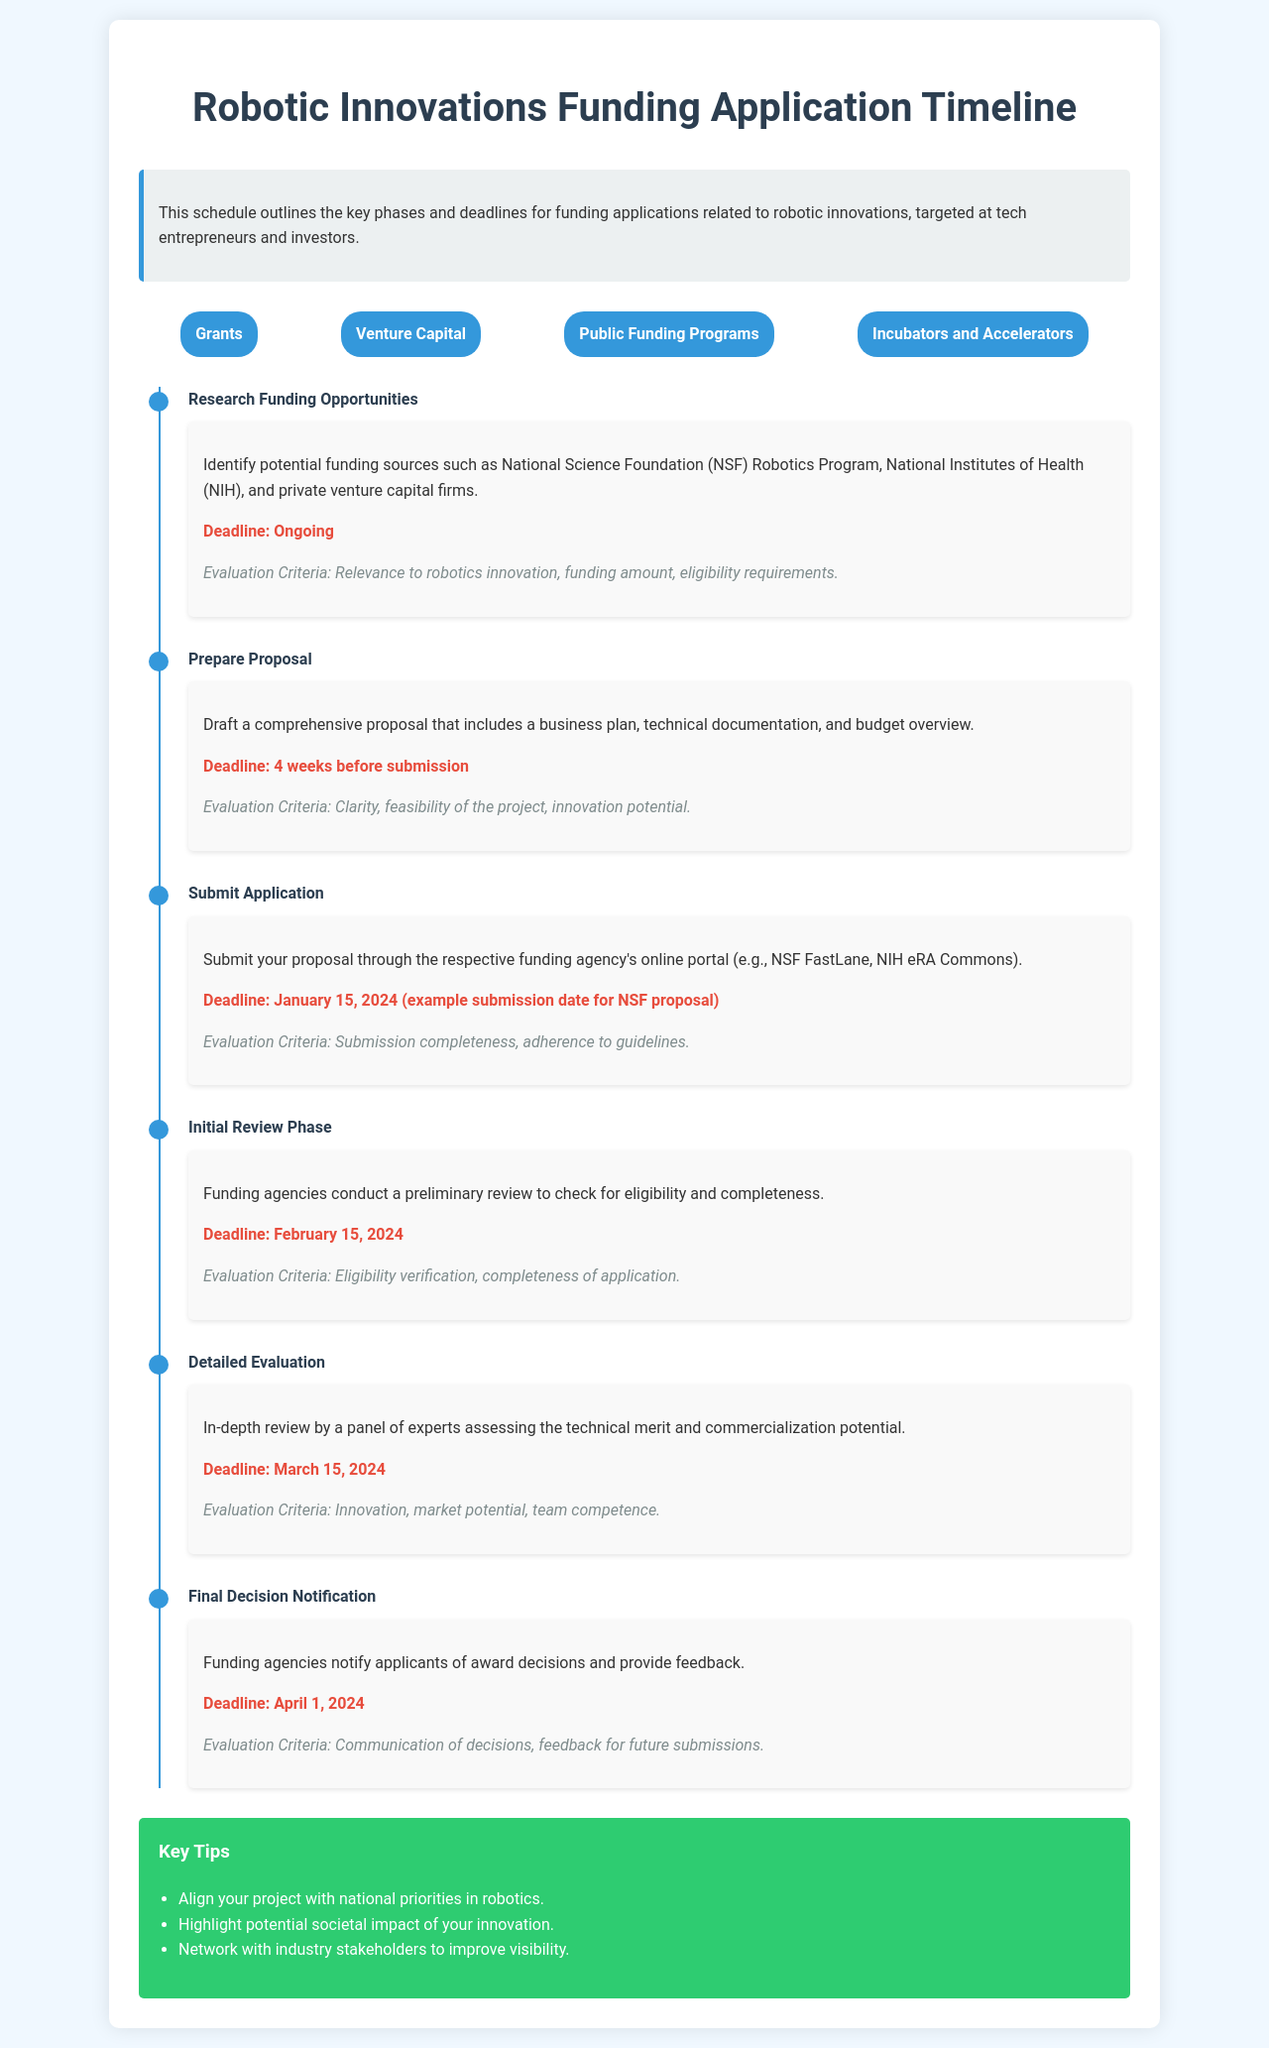what is the deadline for proposal preparation? The proposal preparation deadline is four weeks before the application submission date.
Answer: 4 weeks before submission what is the deadline for submitting the application? The application submission deadline is explicitly stated in the timeline.
Answer: January 15, 2024 what happens during the Initial Review Phase? The Initial Review Phase involves a preliminary check for eligibility and completeness by funding agencies.
Answer: Eligibility check what is the focus area related to government funding? One of the focus areas listed in the document pertains to government support initiatives.
Answer: Public Funding Programs what is evaluated during the Detailed Evaluation phase? The Detailed Evaluation phase assesses the technical merit and commercialization potential.
Answer: Technical merit and commercialization potential how long does it take until applicants are notified of the final decision? The final decision notification date is stated as well as the previous deadlines leading to it.
Answer: 16 days which funding agency is mentioned for robotics programs? The National Science Foundation is highlighted as a funding source for robotics.
Answer: National Science Foundation what are the two major evaluation criteria during the Detailed Evaluation? The criteria considered in the Detailed Evaluation phase can involve assessing team competence and market potential.
Answer: Innovation, market potential, team competence what type of document is outlined in this schedule? This document specifically outlines a funding application timeline for robotics initiatives.
Answer: Funding application timeline 